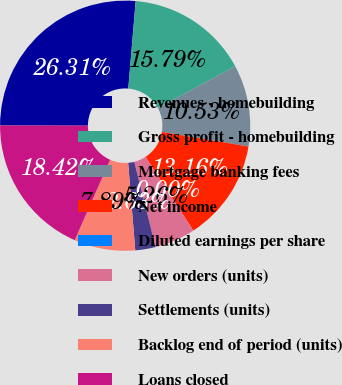Convert chart. <chart><loc_0><loc_0><loc_500><loc_500><pie_chart><fcel>Revenues - homebuilding<fcel>Gross profit - homebuilding<fcel>Mortgage banking fees<fcel>Net income<fcel>Diluted earnings per share<fcel>New orders (units)<fcel>Settlements (units)<fcel>Backlog end of period (units)<fcel>Loans closed<nl><fcel>26.31%<fcel>15.79%<fcel>10.53%<fcel>13.16%<fcel>0.0%<fcel>5.26%<fcel>2.63%<fcel>7.89%<fcel>18.42%<nl></chart> 